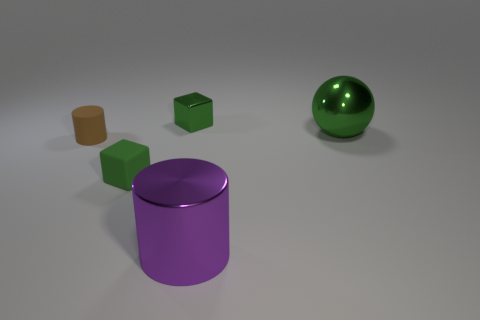Subtract all red cylinders. Subtract all purple balls. How many cylinders are left? 2 Add 5 small green cubes. How many objects exist? 10 Subtract all cylinders. How many objects are left? 3 Add 1 purple cylinders. How many purple cylinders are left? 2 Add 4 green blocks. How many green blocks exist? 6 Subtract 0 yellow cylinders. How many objects are left? 5 Subtract all tiny brown cylinders. Subtract all brown cylinders. How many objects are left? 3 